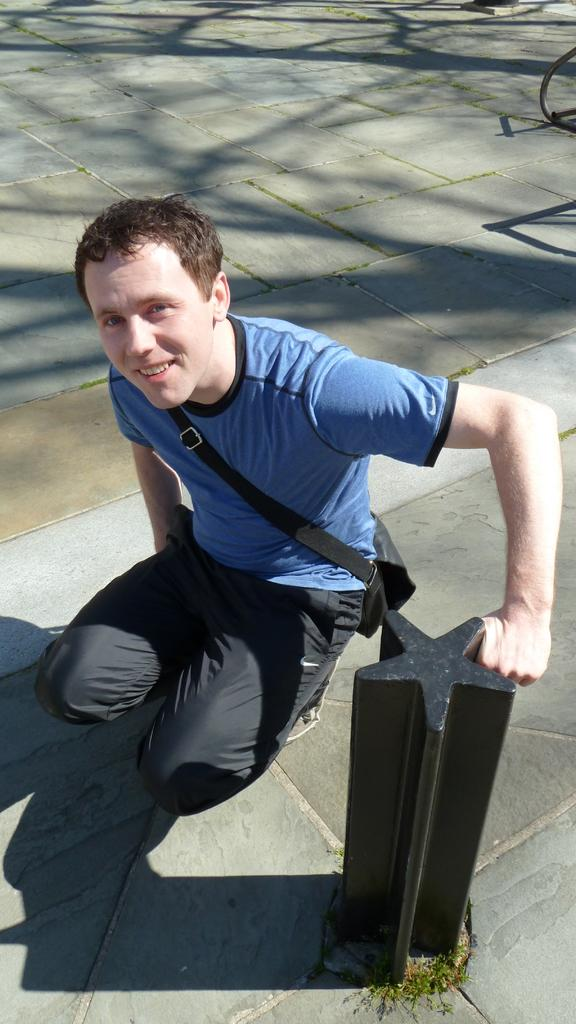What is the person in the image doing? The person is sitting in the image. What is the person wearing that is visible in the image? The person is wearing a bag. What is the person holding in the image? The person is holding a pole. What is the person's facial expression in the image? The person is smiling. What can be seen in the background of the image? There is: There is a shadow of trees in the background of the image. What country is the person in the image visiting? The image does not provide any information about the country the person is visiting. 